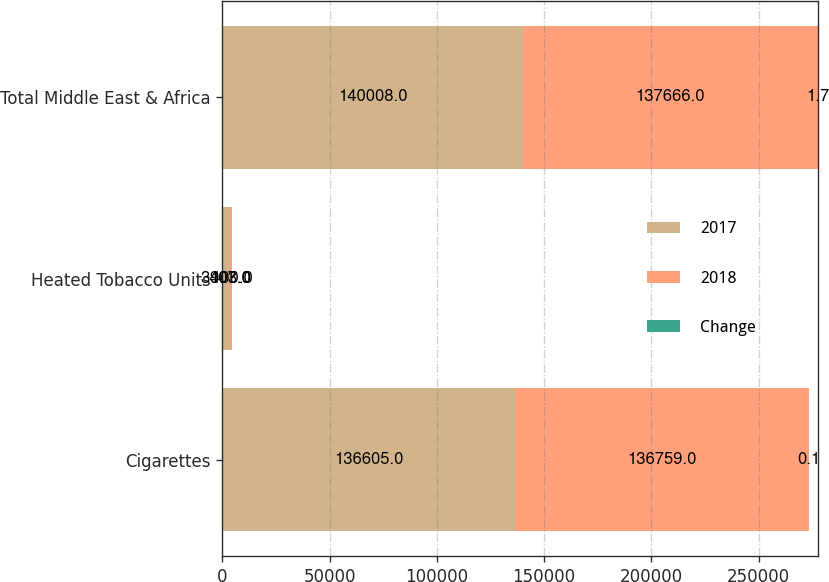Convert chart. <chart><loc_0><loc_0><loc_500><loc_500><stacked_bar_chart><ecel><fcel>Cigarettes<fcel>Heated Tobacco Units<fcel>Total Middle East & Africa<nl><fcel>2017<fcel>136605<fcel>3403<fcel>140008<nl><fcel>2018<fcel>136759<fcel>907<fcel>137666<nl><fcel>Change<fcel>0.1<fcel>100<fcel>1.7<nl></chart> 